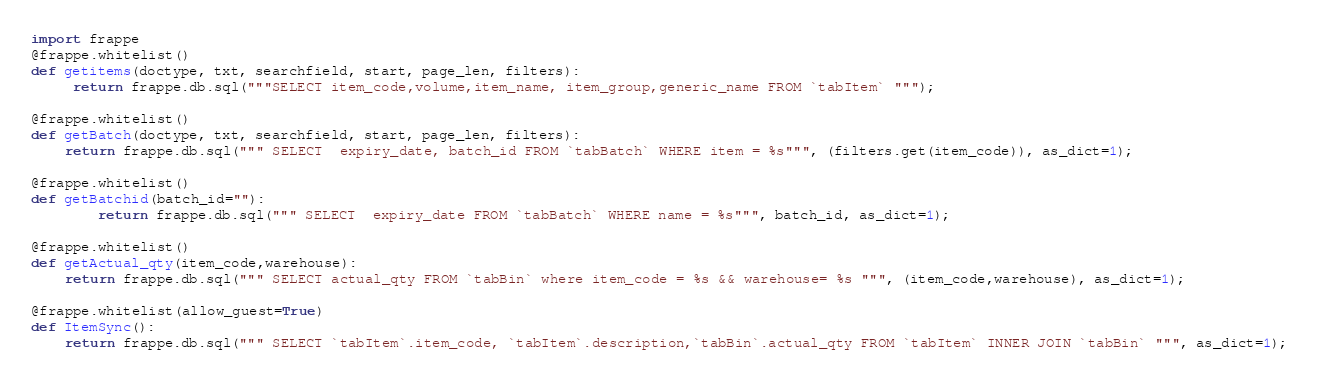<code> <loc_0><loc_0><loc_500><loc_500><_Python_>import frappe
@frappe.whitelist()
def getitems(doctype, txt, searchfield, start, page_len, filters):
     return frappe.db.sql("""SELECT item_code,volume,item_name, item_group,generic_name FROM `tabItem` """);

@frappe.whitelist()
def getBatch(doctype, txt, searchfield, start, page_len, filters):
	return frappe.db.sql(""" SELECT  expiry_date, batch_id FROM `tabBatch` WHERE item = %s""", (filters.get(item_code)), as_dict=1);

@frappe.whitelist()
def getBatchid(batch_id=""):
		return frappe.db.sql(""" SELECT  expiry_date FROM `tabBatch` WHERE name = %s""", batch_id, as_dict=1);

@frappe.whitelist()
def getActual_qty(item_code,warehouse):
	return frappe.db.sql(""" SELECT actual_qty FROM `tabBin` where item_code = %s && warehouse= %s """, (item_code,warehouse), as_dict=1);

@frappe.whitelist(allow_guest=True)
def ItemSync():
	return frappe.db.sql(""" SELECT `tabItem`.item_code, `tabItem`.description,`tabBin`.actual_qty FROM `tabItem` INNER JOIN `tabBin` """, as_dict=1);
</code> 